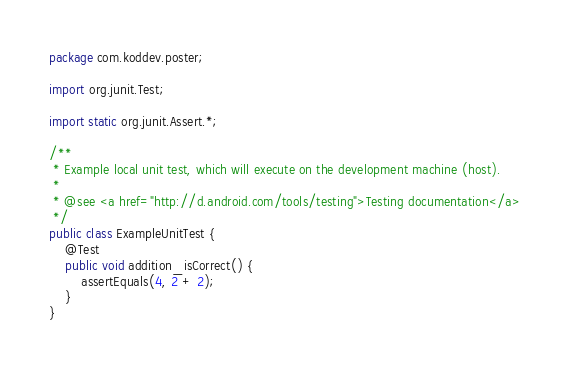Convert code to text. <code><loc_0><loc_0><loc_500><loc_500><_Java_>package com.koddev.poster;

import org.junit.Test;

import static org.junit.Assert.*;

/**
 * Example local unit test, which will execute on the development machine (host).
 *
 * @see <a href="http://d.android.com/tools/testing">Testing documentation</a>
 */
public class ExampleUnitTest {
    @Test
    public void addition_isCorrect() {
        assertEquals(4, 2 + 2);
    }
}</code> 